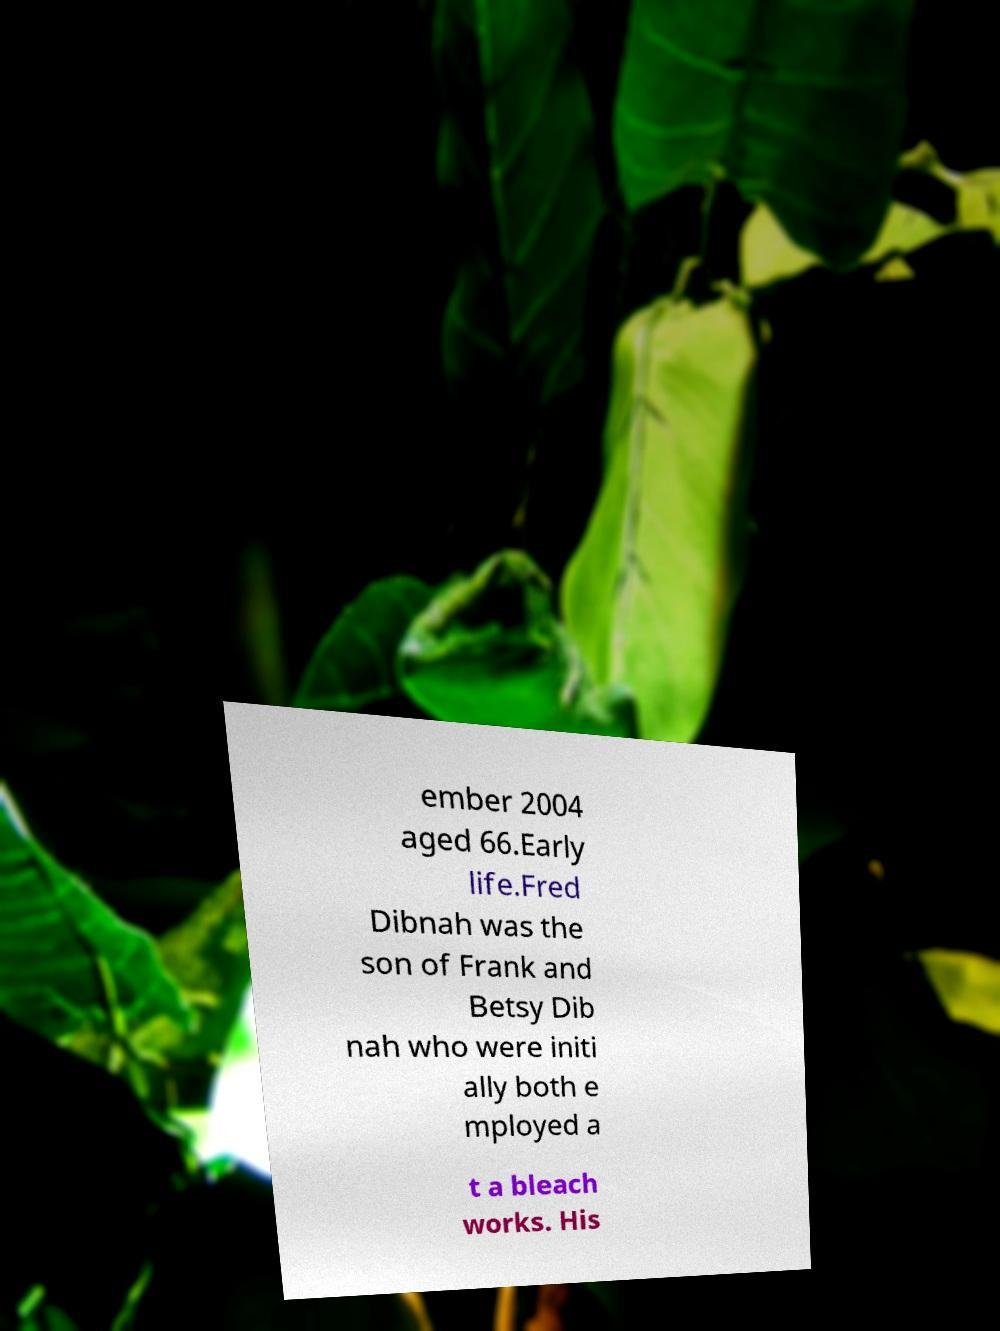Please read and relay the text visible in this image. What does it say? ember 2004 aged 66.Early life.Fred Dibnah was the son of Frank and Betsy Dib nah who were initi ally both e mployed a t a bleach works. His 